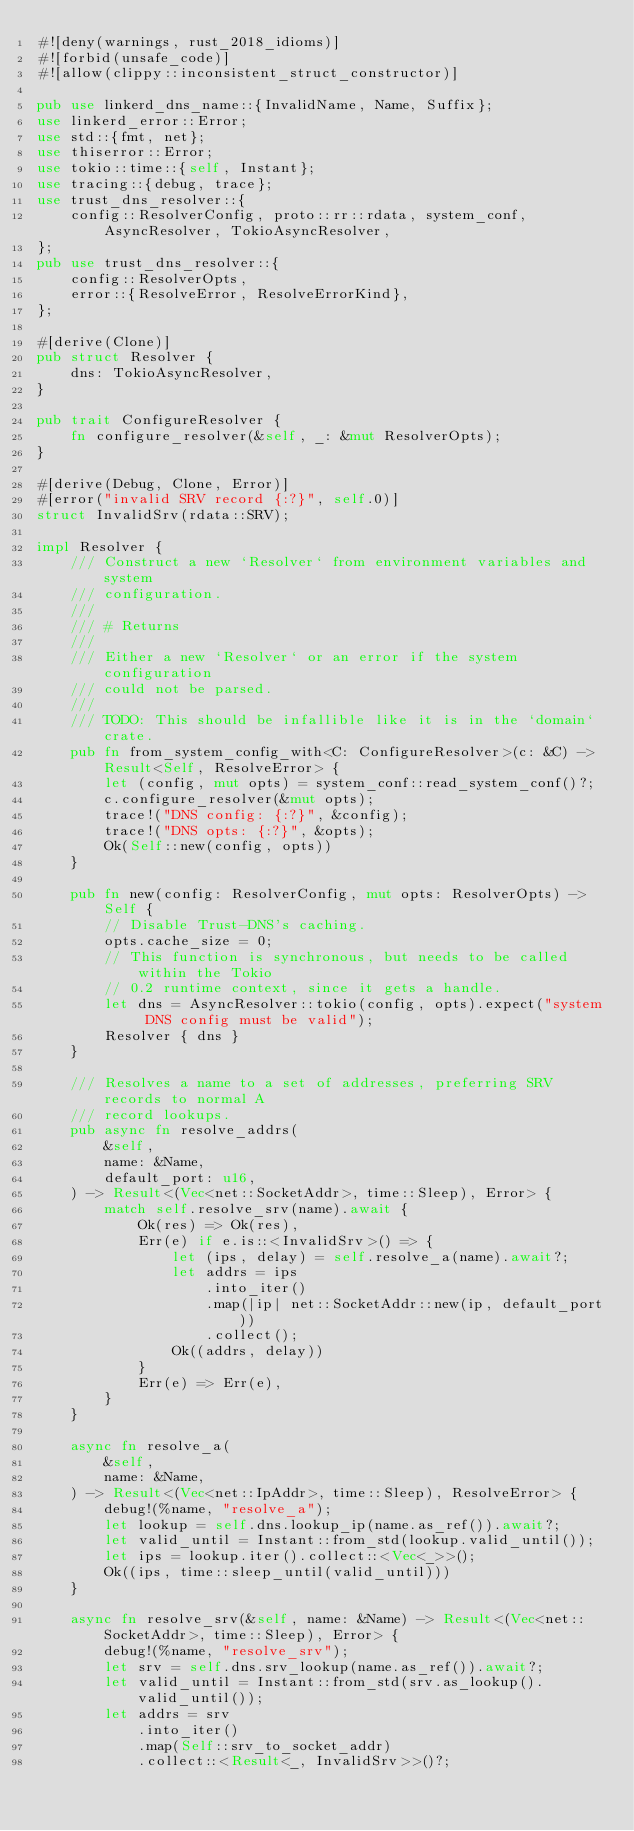<code> <loc_0><loc_0><loc_500><loc_500><_Rust_>#![deny(warnings, rust_2018_idioms)]
#![forbid(unsafe_code)]
#![allow(clippy::inconsistent_struct_constructor)]

pub use linkerd_dns_name::{InvalidName, Name, Suffix};
use linkerd_error::Error;
use std::{fmt, net};
use thiserror::Error;
use tokio::time::{self, Instant};
use tracing::{debug, trace};
use trust_dns_resolver::{
    config::ResolverConfig, proto::rr::rdata, system_conf, AsyncResolver, TokioAsyncResolver,
};
pub use trust_dns_resolver::{
    config::ResolverOpts,
    error::{ResolveError, ResolveErrorKind},
};

#[derive(Clone)]
pub struct Resolver {
    dns: TokioAsyncResolver,
}

pub trait ConfigureResolver {
    fn configure_resolver(&self, _: &mut ResolverOpts);
}

#[derive(Debug, Clone, Error)]
#[error("invalid SRV record {:?}", self.0)]
struct InvalidSrv(rdata::SRV);

impl Resolver {
    /// Construct a new `Resolver` from environment variables and system
    /// configuration.
    ///
    /// # Returns
    ///
    /// Either a new `Resolver` or an error if the system configuration
    /// could not be parsed.
    ///
    /// TODO: This should be infallible like it is in the `domain` crate.
    pub fn from_system_config_with<C: ConfigureResolver>(c: &C) -> Result<Self, ResolveError> {
        let (config, mut opts) = system_conf::read_system_conf()?;
        c.configure_resolver(&mut opts);
        trace!("DNS config: {:?}", &config);
        trace!("DNS opts: {:?}", &opts);
        Ok(Self::new(config, opts))
    }

    pub fn new(config: ResolverConfig, mut opts: ResolverOpts) -> Self {
        // Disable Trust-DNS's caching.
        opts.cache_size = 0;
        // This function is synchronous, but needs to be called within the Tokio
        // 0.2 runtime context, since it gets a handle.
        let dns = AsyncResolver::tokio(config, opts).expect("system DNS config must be valid");
        Resolver { dns }
    }

    /// Resolves a name to a set of addresses, preferring SRV records to normal A
    /// record lookups.
    pub async fn resolve_addrs(
        &self,
        name: &Name,
        default_port: u16,
    ) -> Result<(Vec<net::SocketAddr>, time::Sleep), Error> {
        match self.resolve_srv(name).await {
            Ok(res) => Ok(res),
            Err(e) if e.is::<InvalidSrv>() => {
                let (ips, delay) = self.resolve_a(name).await?;
                let addrs = ips
                    .into_iter()
                    .map(|ip| net::SocketAddr::new(ip, default_port))
                    .collect();
                Ok((addrs, delay))
            }
            Err(e) => Err(e),
        }
    }

    async fn resolve_a(
        &self,
        name: &Name,
    ) -> Result<(Vec<net::IpAddr>, time::Sleep), ResolveError> {
        debug!(%name, "resolve_a");
        let lookup = self.dns.lookup_ip(name.as_ref()).await?;
        let valid_until = Instant::from_std(lookup.valid_until());
        let ips = lookup.iter().collect::<Vec<_>>();
        Ok((ips, time::sleep_until(valid_until)))
    }

    async fn resolve_srv(&self, name: &Name) -> Result<(Vec<net::SocketAddr>, time::Sleep), Error> {
        debug!(%name, "resolve_srv");
        let srv = self.dns.srv_lookup(name.as_ref()).await?;
        let valid_until = Instant::from_std(srv.as_lookup().valid_until());
        let addrs = srv
            .into_iter()
            .map(Self::srv_to_socket_addr)
            .collect::<Result<_, InvalidSrv>>()?;</code> 